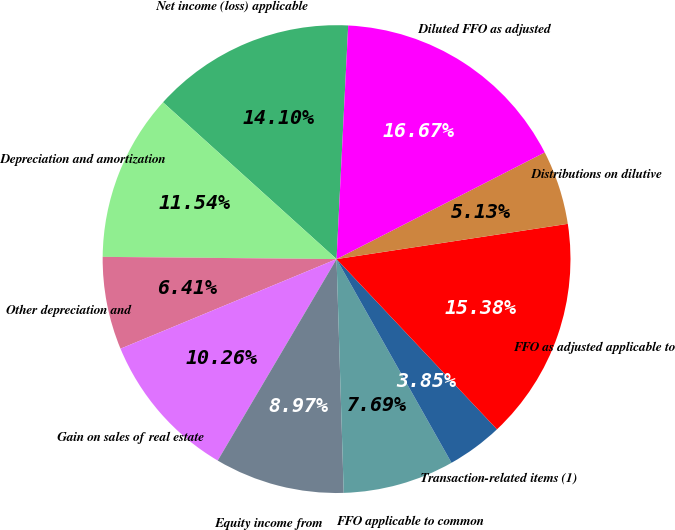Convert chart. <chart><loc_0><loc_0><loc_500><loc_500><pie_chart><fcel>Net income (loss) applicable<fcel>Depreciation and amortization<fcel>Other depreciation and<fcel>Gain on sales of real estate<fcel>Equity income from<fcel>FFO applicable to common<fcel>Transaction-related items (1)<fcel>FFO as adjusted applicable to<fcel>Distributions on dilutive<fcel>Diluted FFO as adjusted<nl><fcel>14.1%<fcel>11.54%<fcel>6.41%<fcel>10.26%<fcel>8.97%<fcel>7.69%<fcel>3.85%<fcel>15.38%<fcel>5.13%<fcel>16.67%<nl></chart> 